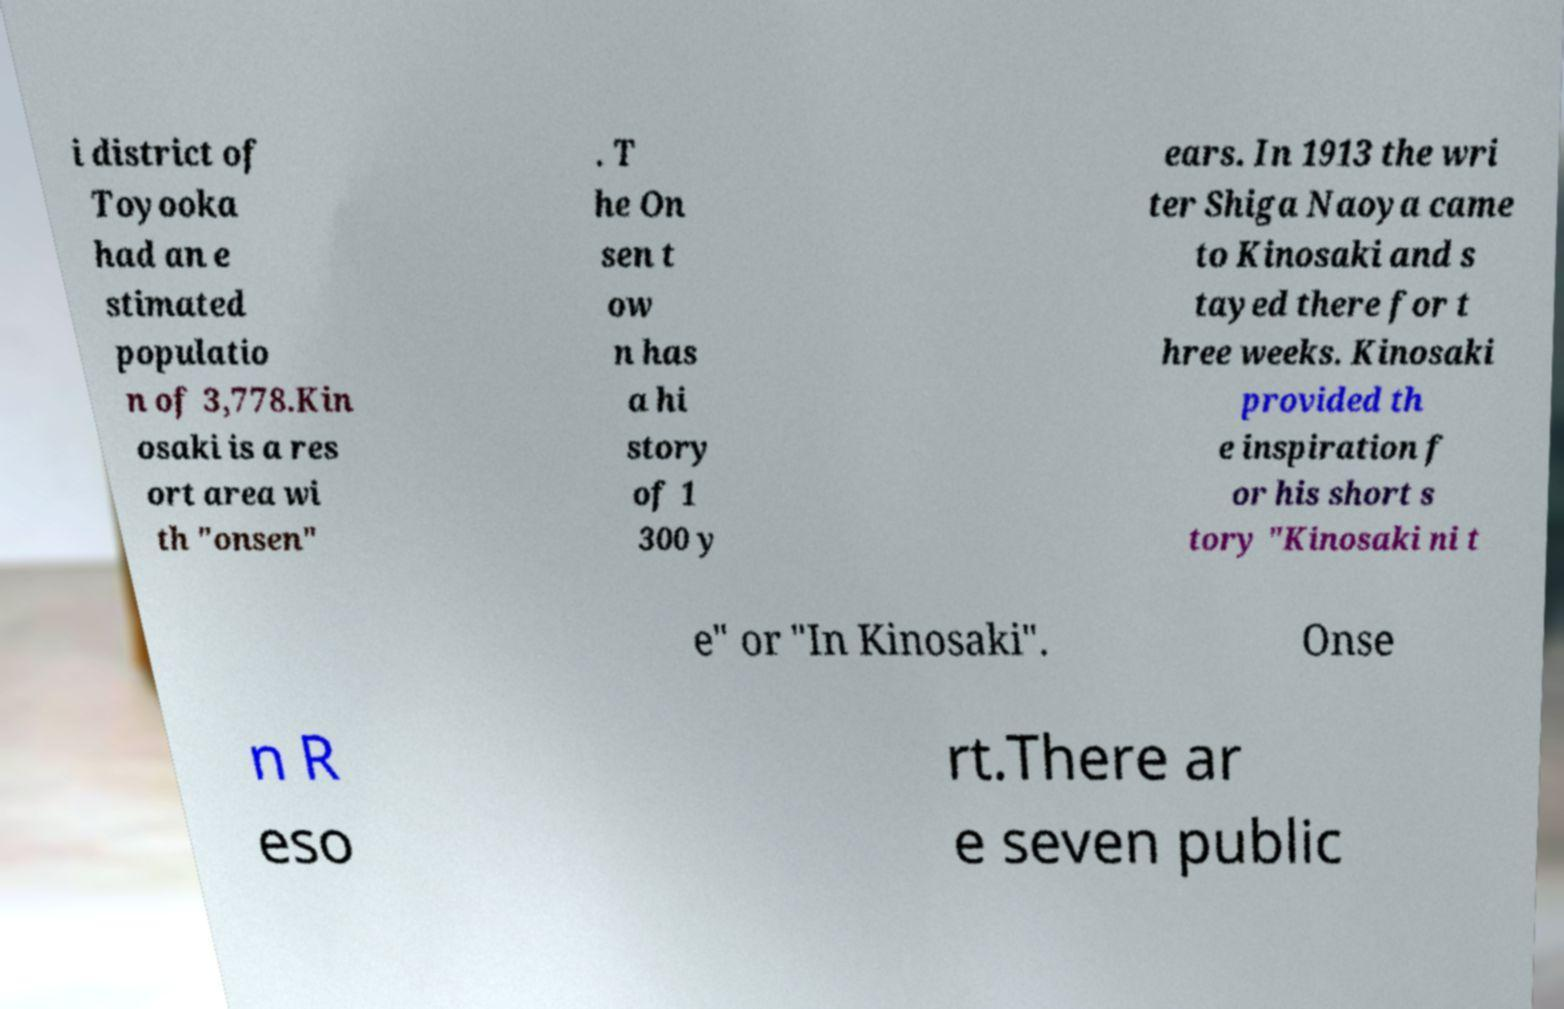Can you accurately transcribe the text from the provided image for me? i district of Toyooka had an e stimated populatio n of 3,778.Kin osaki is a res ort area wi th "onsen" . T he On sen t ow n has a hi story of 1 300 y ears. In 1913 the wri ter Shiga Naoya came to Kinosaki and s tayed there for t hree weeks. Kinosaki provided th e inspiration f or his short s tory "Kinosaki ni t e" or "In Kinosaki". Onse n R eso rt.There ar e seven public 